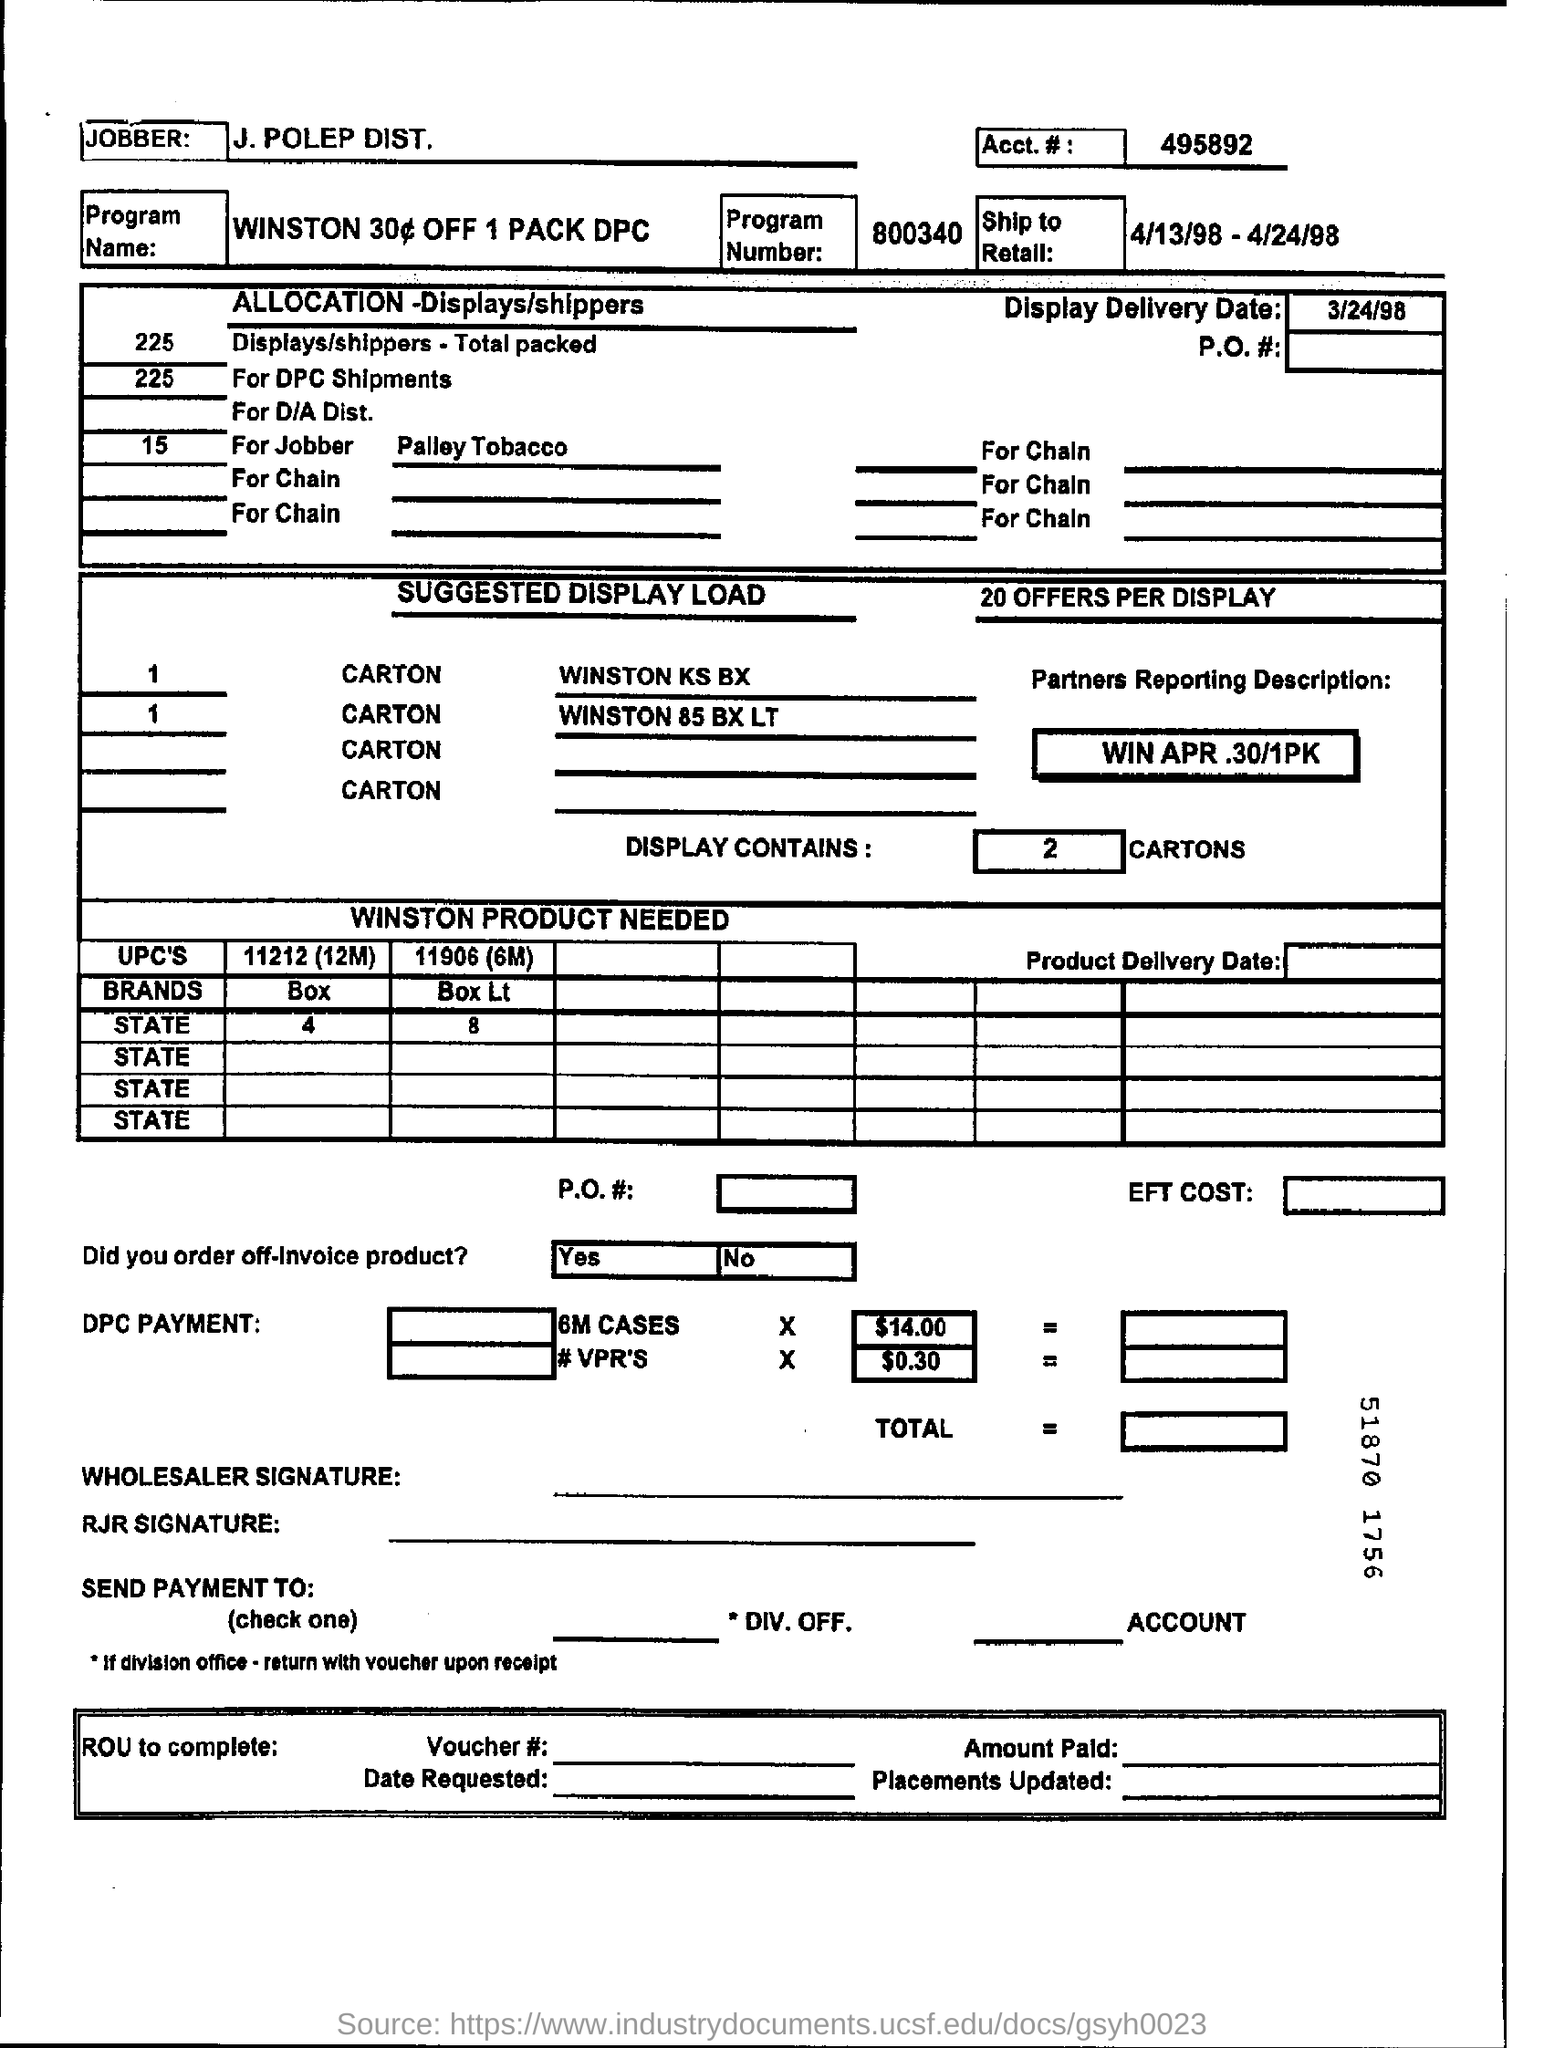Mention a couple of crucial points in this snapshot. Display contains two cartons. The program number is 800340... The jobber in question is J. Polep Distributors. The display delivery date is March 24, 1998. 